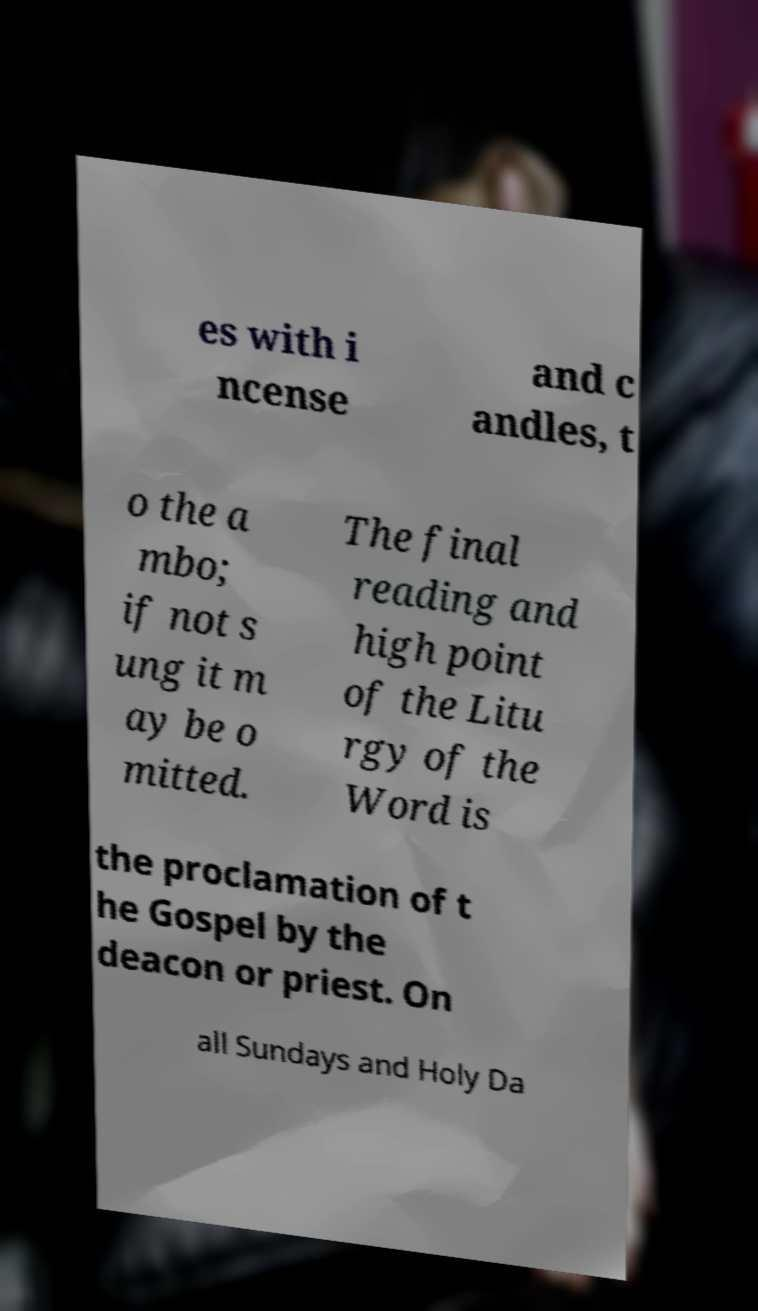Please identify and transcribe the text found in this image. es with i ncense and c andles, t o the a mbo; if not s ung it m ay be o mitted. The final reading and high point of the Litu rgy of the Word is the proclamation of t he Gospel by the deacon or priest. On all Sundays and Holy Da 